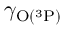Convert formula to latex. <formula><loc_0><loc_0><loc_500><loc_500>\gamma _ { O ( ^ { 3 } P ) }</formula> 